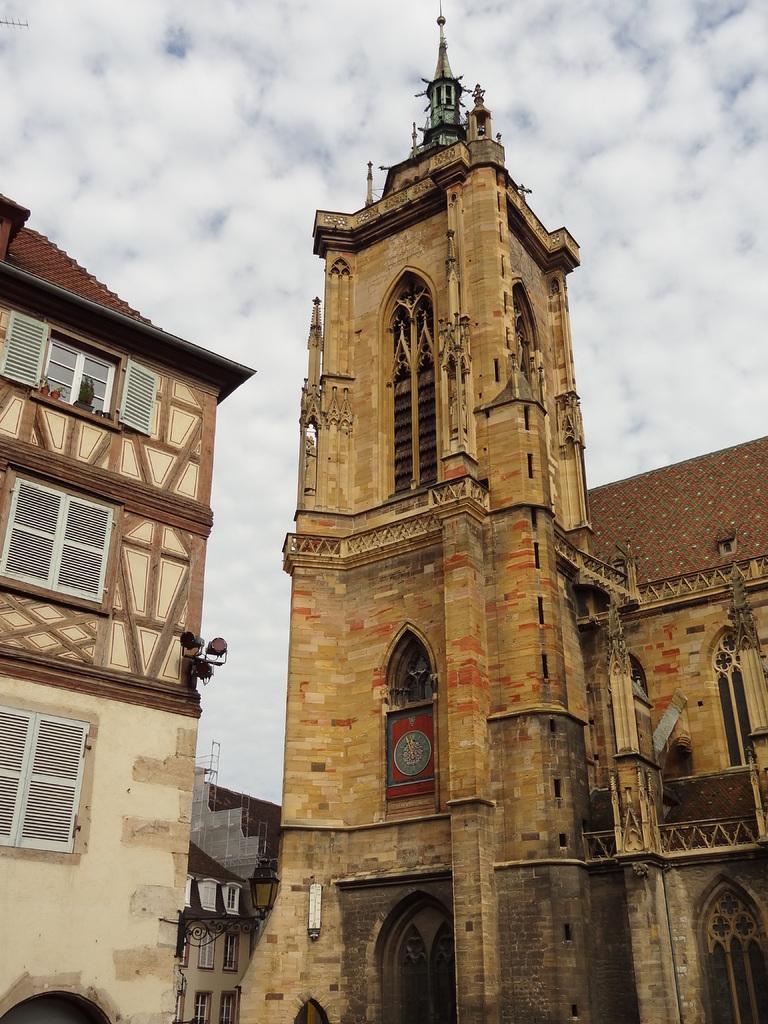Could you give a brief overview of what you see in this image? In the picture we can see a church building and opposite to it, we can see a part of another building with windows and in the background we can see the sky with clouds. 